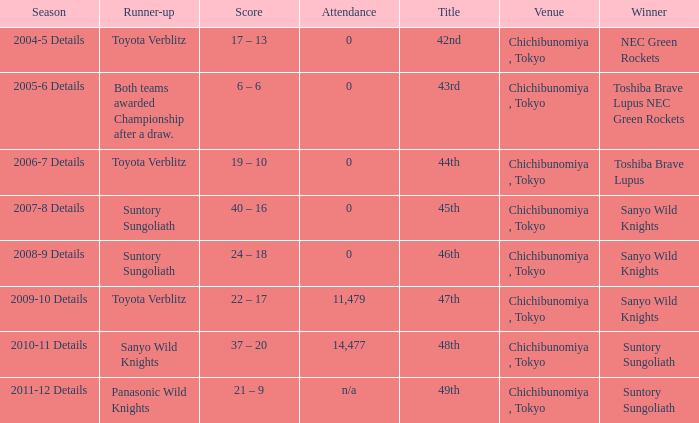What is the Score when the winner was sanyo wild knights, and a Runner-up of suntory sungoliath? 40 – 16, 24 – 18. 